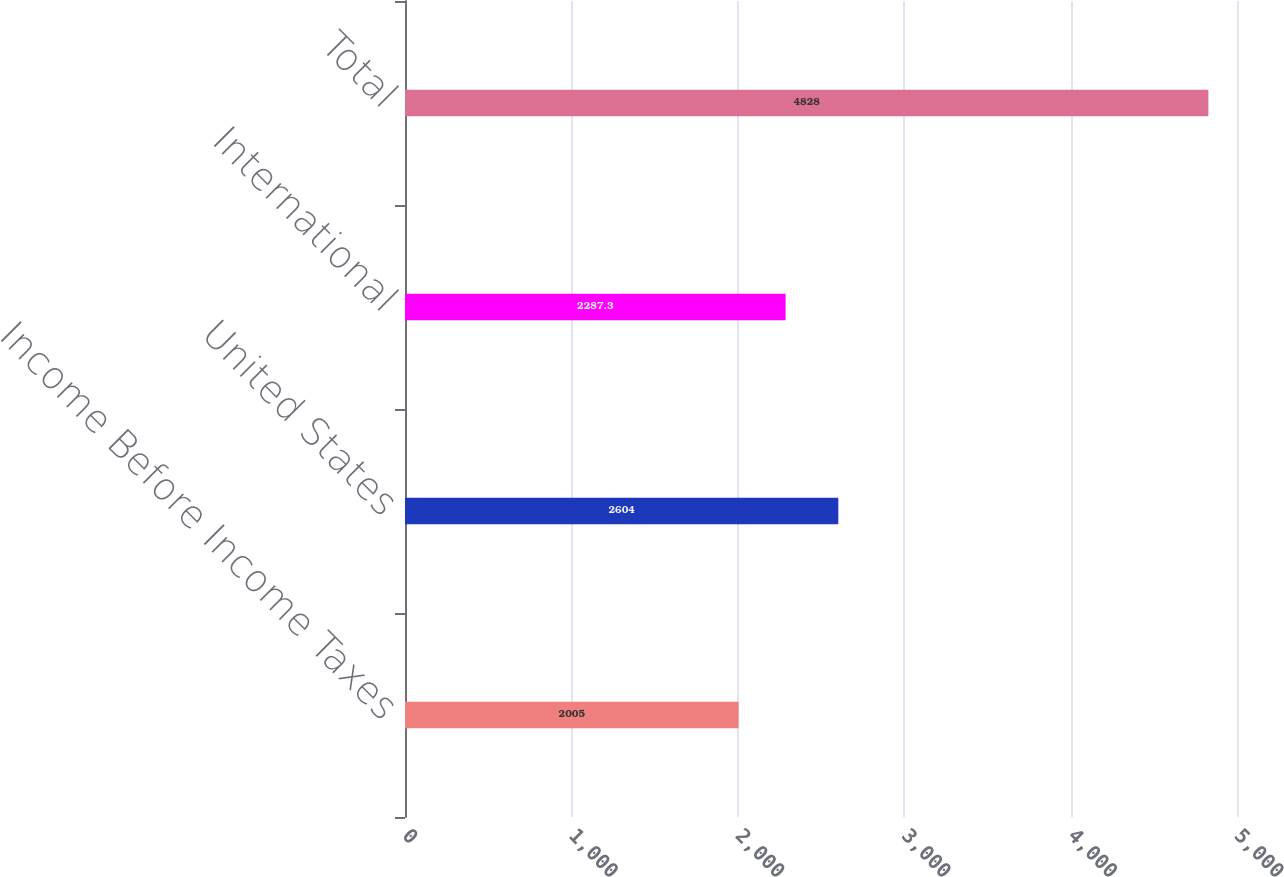Convert chart. <chart><loc_0><loc_0><loc_500><loc_500><bar_chart><fcel>Income Before Income Taxes<fcel>United States<fcel>International<fcel>Total<nl><fcel>2005<fcel>2604<fcel>2287.3<fcel>4828<nl></chart> 